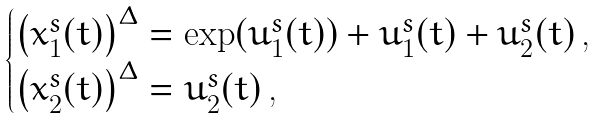Convert formula to latex. <formula><loc_0><loc_0><loc_500><loc_500>\begin{cases} \left ( x _ { 1 } ^ { s } ( t ) \right ) ^ { \Delta } = \exp ( u _ { 1 } ^ { s } ( t ) ) + u _ { 1 } ^ { s } ( t ) + u _ { 2 } ^ { s } ( t ) \, , \\ \left ( x _ { 2 } ^ { s } ( t ) \right ) ^ { \Delta } = u _ { 2 } ^ { s } ( t ) \, , \end{cases}</formula> 